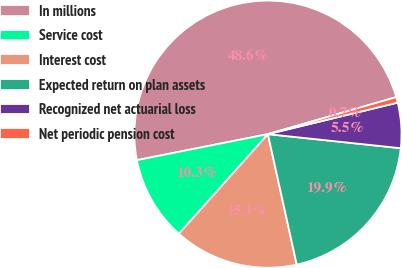<chart> <loc_0><loc_0><loc_500><loc_500><pie_chart><fcel>In millions<fcel>Service cost<fcel>Interest cost<fcel>Expected return on plan assets<fcel>Recognized net actuarial loss<fcel>Net periodic pension cost<nl><fcel>48.65%<fcel>10.27%<fcel>15.07%<fcel>19.86%<fcel>5.47%<fcel>0.68%<nl></chart> 